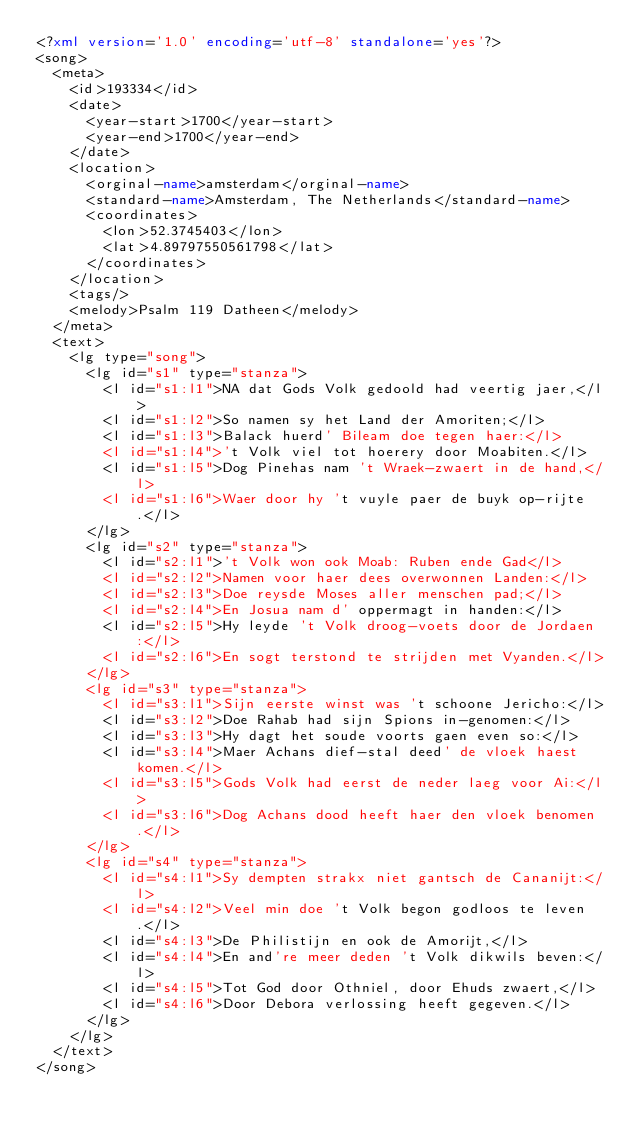Convert code to text. <code><loc_0><loc_0><loc_500><loc_500><_XML_><?xml version='1.0' encoding='utf-8' standalone='yes'?>
<song>
  <meta>
    <id>193334</id>
    <date>
      <year-start>1700</year-start>
      <year-end>1700</year-end>
    </date>
    <location>
      <orginal-name>amsterdam</orginal-name>
      <standard-name>Amsterdam, The Netherlands</standard-name>
      <coordinates>
        <lon>52.3745403</lon>
        <lat>4.89797550561798</lat>
      </coordinates>
    </location>
    <tags/>
    <melody>Psalm 119 Datheen</melody>
  </meta>
  <text>
    <lg type="song">
      <lg id="s1" type="stanza">
        <l id="s1:l1">NA dat Gods Volk gedoold had veertig jaer,</l>
        <l id="s1:l2">So namen sy het Land der Amoriten;</l>
        <l id="s1:l3">Balack huerd' Bileam doe tegen haer:</l>
        <l id="s1:l4">'t Volk viel tot hoerery door Moabiten.</l>
        <l id="s1:l5">Dog Pinehas nam 't Wraek-zwaert in de hand,</l>
        <l id="s1:l6">Waer door hy 't vuyle paer de buyk op-rijte.</l>
      </lg>
      <lg id="s2" type="stanza">
        <l id="s2:l1">'t Volk won ook Moab: Ruben ende Gad</l>
        <l id="s2:l2">Namen voor haer dees overwonnen Landen:</l>
        <l id="s2:l3">Doe reysde Moses aller menschen pad;</l>
        <l id="s2:l4">En Josua nam d' oppermagt in handen:</l>
        <l id="s2:l5">Hy leyde 't Volk droog-voets door de Jordaen:</l>
        <l id="s2:l6">En sogt terstond te strijden met Vyanden.</l>
      </lg>
      <lg id="s3" type="stanza">
        <l id="s3:l1">Sijn eerste winst was 't schoone Jericho:</l>
        <l id="s3:l2">Doe Rahab had sijn Spions in-genomen:</l>
        <l id="s3:l3">Hy dagt het soude voorts gaen even so:</l>
        <l id="s3:l4">Maer Achans dief-stal deed' de vloek haest komen.</l>
        <l id="s3:l5">Gods Volk had eerst de neder laeg voor Ai:</l>
        <l id="s3:l6">Dog Achans dood heeft haer den vloek benomen.</l>
      </lg>
      <lg id="s4" type="stanza">
        <l id="s4:l1">Sy dempten strakx niet gantsch de Cananijt:</l>
        <l id="s4:l2">Veel min doe 't Volk begon godloos te leven.</l>
        <l id="s4:l3">De Philistijn en ook de Amorijt,</l>
        <l id="s4:l4">En and're meer deden 't Volk dikwils beven:</l>
        <l id="s4:l5">Tot God door Othniel, door Ehuds zwaert,</l>
        <l id="s4:l6">Door Debora verlossing heeft gegeven.</l>
      </lg>
    </lg>
  </text>
</song>
</code> 